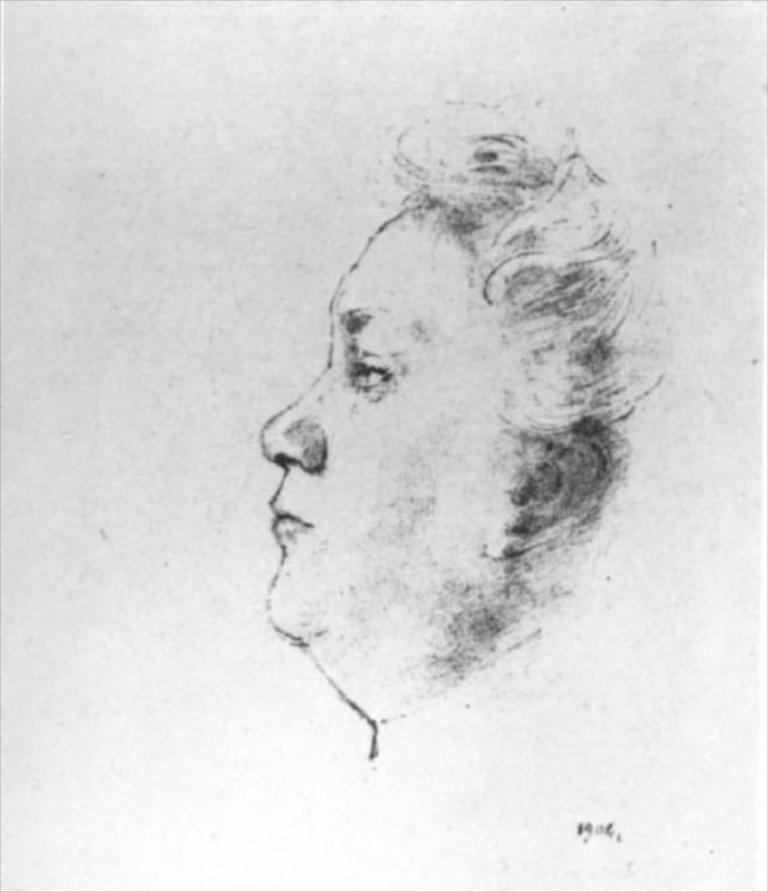In one or two sentences, can you explain what this image depicts? In this picture we can able to see a pencil sketch of a person. 